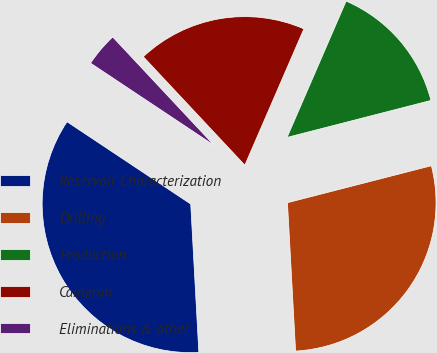Convert chart. <chart><loc_0><loc_0><loc_500><loc_500><pie_chart><fcel>Reservoir Characterization<fcel>Drilling<fcel>Production<fcel>Cameron<fcel>Eliminations & other<nl><fcel>35.21%<fcel>28.13%<fcel>14.49%<fcel>18.48%<fcel>3.68%<nl></chart> 